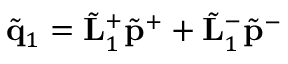<formula> <loc_0><loc_0><loc_500><loc_500>\tilde { q } _ { 1 } = \tilde { L } _ { 1 } ^ { + } \tilde { p } ^ { + } + \tilde { L } _ { 1 } ^ { - } \tilde { p } ^ { - }</formula> 